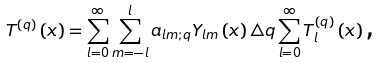Convert formula to latex. <formula><loc_0><loc_0><loc_500><loc_500>T ^ { \left ( q \right ) } \left ( x \right ) = \sum _ { l = 0 } ^ { \infty } \sum _ { m = - l } ^ { l } a _ { l m ; q } Y _ { l m } \left ( x \right ) \triangle q \sum _ { l = 0 } ^ { \infty } T _ { l } ^ { \left ( q \right ) } \left ( x \right ) \text {,}</formula> 